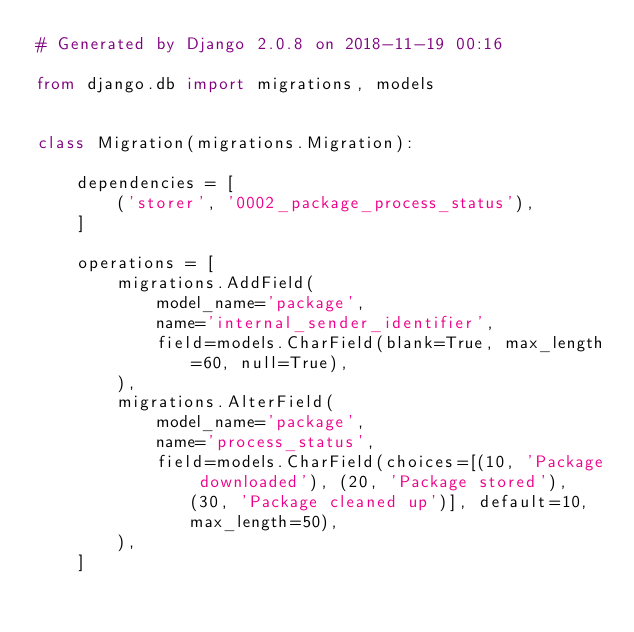Convert code to text. <code><loc_0><loc_0><loc_500><loc_500><_Python_># Generated by Django 2.0.8 on 2018-11-19 00:16

from django.db import migrations, models


class Migration(migrations.Migration):

    dependencies = [
        ('storer', '0002_package_process_status'),
    ]

    operations = [
        migrations.AddField(
            model_name='package',
            name='internal_sender_identifier',
            field=models.CharField(blank=True, max_length=60, null=True),
        ),
        migrations.AlterField(
            model_name='package',
            name='process_status',
            field=models.CharField(choices=[(10, 'Package downloaded'), (20, 'Package stored'), (30, 'Package cleaned up')], default=10, max_length=50),
        ),
    ]
</code> 